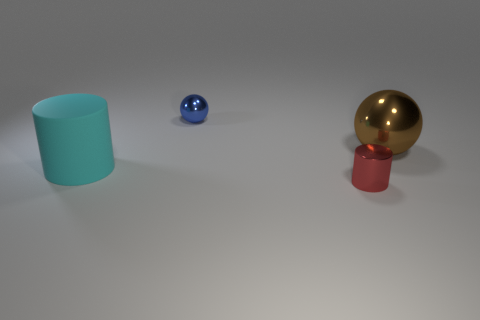Add 1 small blue balls. How many objects exist? 5 Add 1 small shiny cylinders. How many small shiny cylinders exist? 2 Subtract 1 red cylinders. How many objects are left? 3 Subtract all large brown metallic things. Subtract all big cyan rubber objects. How many objects are left? 2 Add 4 metal things. How many metal things are left? 7 